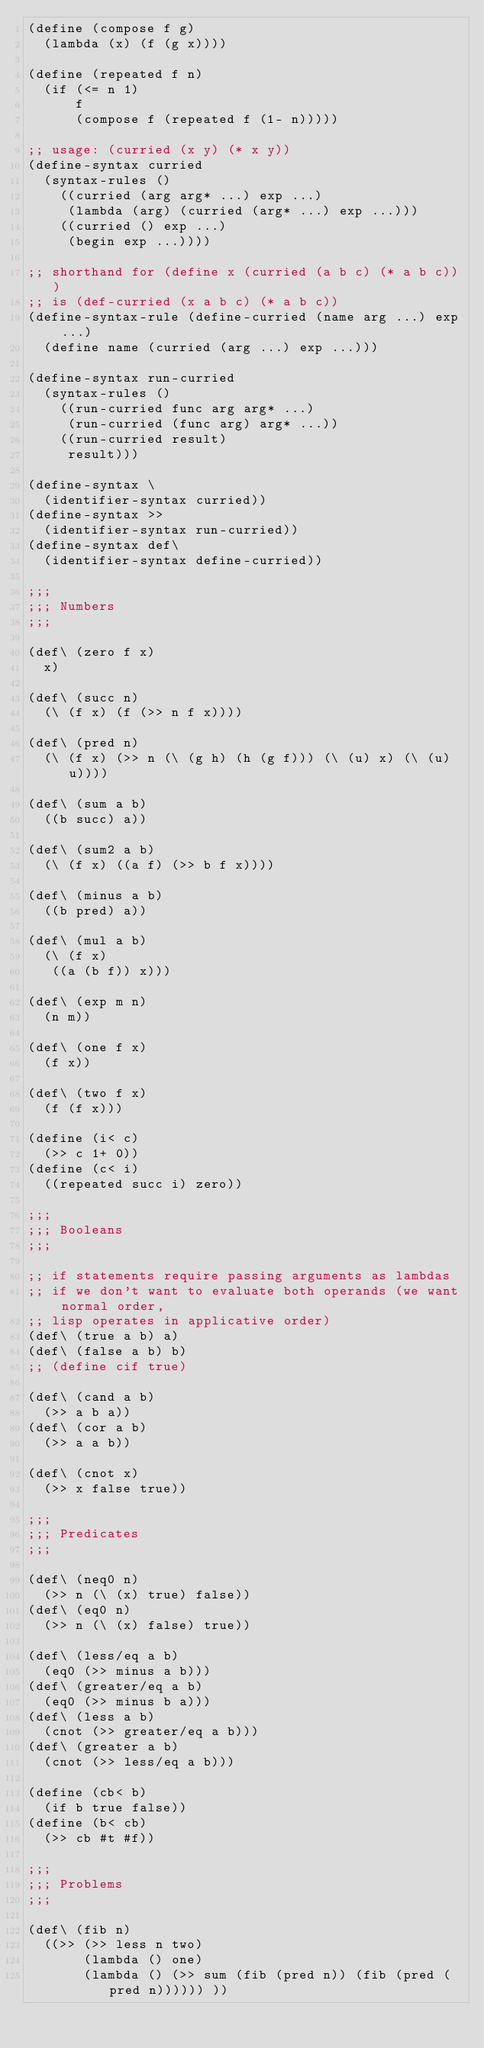<code> <loc_0><loc_0><loc_500><loc_500><_Scheme_>(define (compose f g)
  (lambda (x) (f (g x))))

(define (repeated f n)
  (if (<= n 1)
      f
      (compose f (repeated f (1- n)))))

;; usage: (curried (x y) (* x y))
(define-syntax curried
  (syntax-rules ()
    ((curried (arg arg* ...) exp ...)
     (lambda (arg) (curried (arg* ...) exp ...)))
    ((curried () exp ...)
     (begin exp ...))))

;; shorthand for (define x (curried (a b c) (* a b c)))
;; is (def-curried (x a b c) (* a b c))
(define-syntax-rule (define-curried (name arg ...) exp ...)
  (define name (curried (arg ...) exp ...)))

(define-syntax run-curried
  (syntax-rules ()
    ((run-curried func arg arg* ...)
     (run-curried (func arg) arg* ...))
    ((run-curried result)
     result)))

(define-syntax \
  (identifier-syntax curried))
(define-syntax >>
  (identifier-syntax run-curried))
(define-syntax def\
  (identifier-syntax define-curried))

;;;
;;; Numbers
;;;

(def\ (zero f x)
  x)

(def\ (succ n)
  (\ (f x) (f (>> n f x))))

(def\ (pred n)
  (\ (f x) (>> n (\ (g h) (h (g f))) (\ (u) x) (\ (u) u))))

(def\ (sum a b)
  ((b succ) a))

(def\ (sum2 a b)
  (\ (f x) ((a f) (>> b f x))))

(def\ (minus a b)
  ((b pred) a))

(def\ (mul a b)
  (\ (f x)
   ((a (b f)) x)))

(def\ (exp m n)
  (n m))

(def\ (one f x)
  (f x))

(def\ (two f x)
  (f (f x)))

(define (i< c)
  (>> c 1+ 0))
(define (c< i)
  ((repeated succ i) zero))

;;;
;;; Booleans
;;;

;; if statements require passing arguments as lambdas
;; if we don't want to evaluate both operands (we want normal order,
;; lisp operates in applicative order)
(def\ (true a b) a)
(def\ (false a b) b)
;; (define cif true)

(def\ (cand a b)
  (>> a b a))
(def\ (cor a b)
  (>> a a b))

(def\ (cnot x)
  (>> x false true))

;;;
;;; Predicates
;;;

(def\ (neq0 n)
  (>> n (\ (x) true) false))
(def\ (eq0 n)
  (>> n (\ (x) false) true))

(def\ (less/eq a b)
  (eq0 (>> minus a b)))
(def\ (greater/eq a b)
  (eq0 (>> minus b a)))
(def\ (less a b)
  (cnot (>> greater/eq a b)))
(def\ (greater a b)
  (cnot (>> less/eq a b)))

(define (cb< b)
  (if b true false))
(define (b< cb)
  (>> cb #t #f))

;;;
;;; Problems
;;;

(def\ (fib n)
  ((>> (>> less n two)
       (lambda () one)
       (lambda () (>> sum (fib (pred n)) (fib (pred (pred n)))))) ))
</code> 